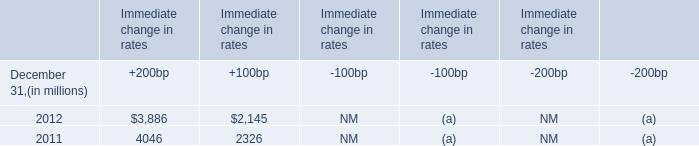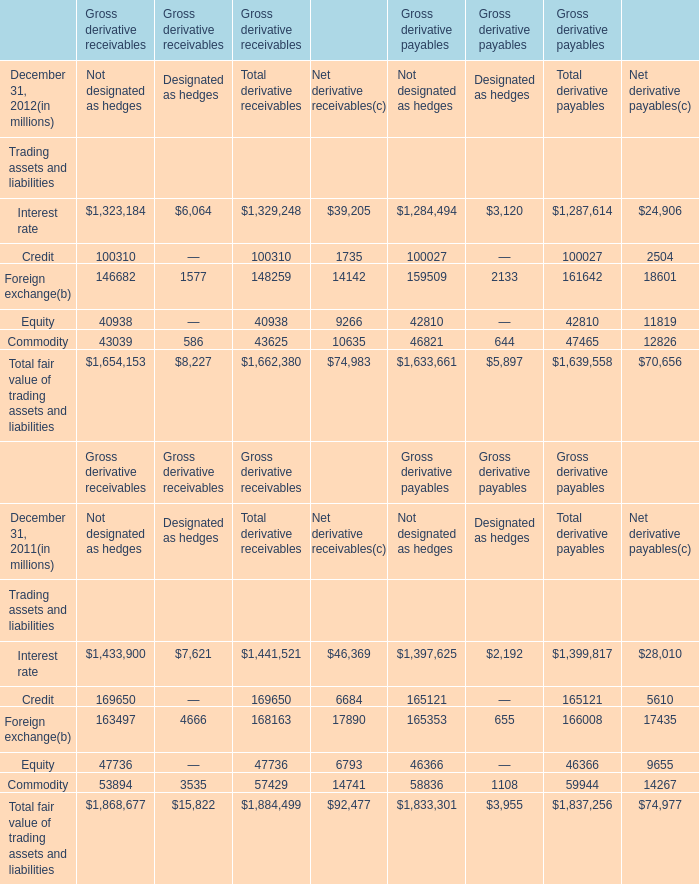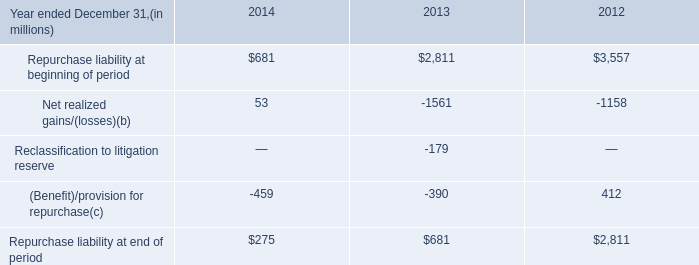What is the difference between 2011 and 2012 's highest element in Not designated as hedges for Gross derivative receivables? (in million) 
Computations: (1654153 - 1868677)
Answer: -214524.0. 